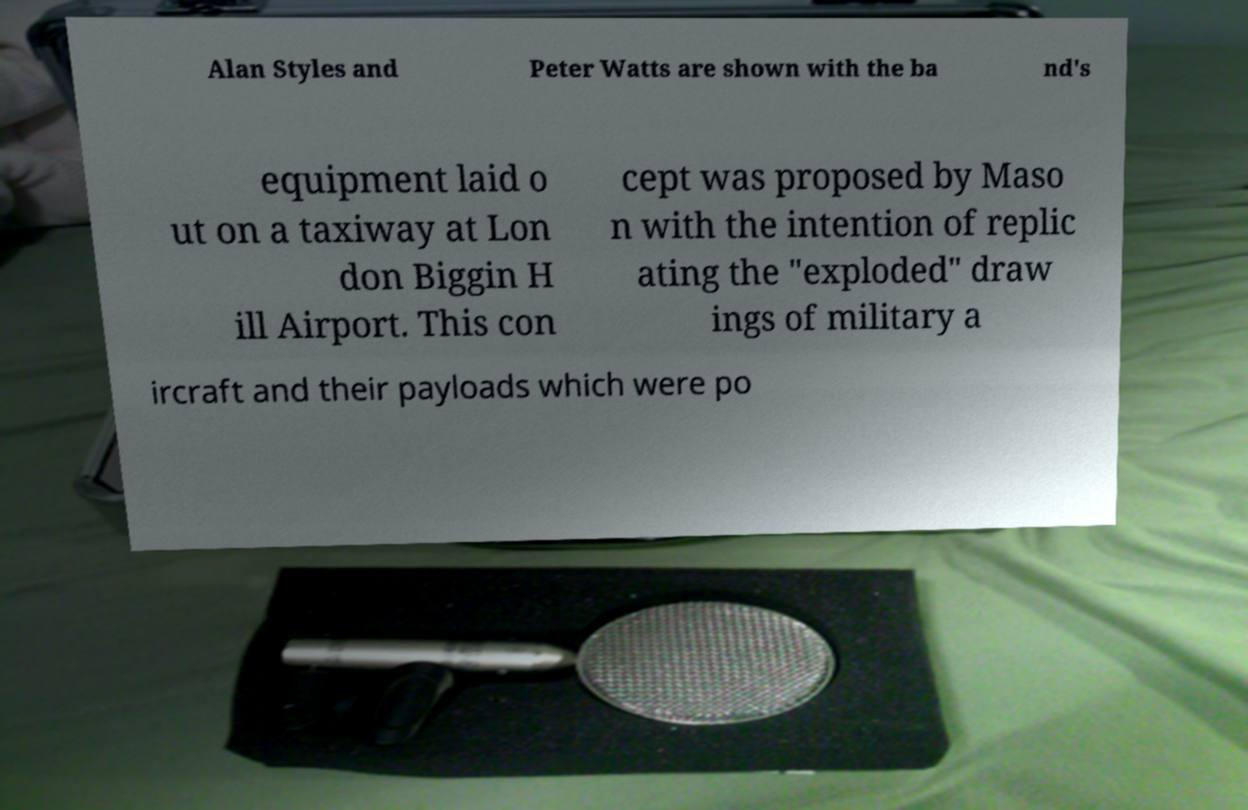Can you read and provide the text displayed in the image?This photo seems to have some interesting text. Can you extract and type it out for me? Alan Styles and Peter Watts are shown with the ba nd's equipment laid o ut on a taxiway at Lon don Biggin H ill Airport. This con cept was proposed by Maso n with the intention of replic ating the "exploded" draw ings of military a ircraft and their payloads which were po 